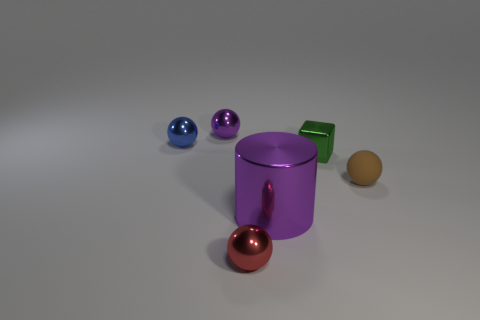What size is the thing that is the same color as the cylinder?
Your answer should be compact. Small. How many matte things are either red balls or cylinders?
Offer a terse response. 0. Is there a tiny blue metal object to the right of the sphere that is on the right side of the metal sphere in front of the matte ball?
Your response must be concise. No. There is a small blue metallic object; how many blue balls are in front of it?
Make the answer very short. 0. There is a object that is the same color as the large cylinder; what is it made of?
Ensure brevity in your answer.  Metal. How many small things are blue blocks or brown rubber objects?
Give a very brief answer. 1. What is the shape of the small red metal object that is in front of the matte sphere?
Keep it short and to the point. Sphere. Are there any spheres of the same color as the tiny block?
Make the answer very short. No. Do the shiny thing to the right of the big purple metallic object and the thing behind the tiny blue metal sphere have the same size?
Offer a very short reply. Yes. Are there more matte objects behind the large purple cylinder than metal spheres on the left side of the tiny blue sphere?
Your answer should be very brief. Yes. 